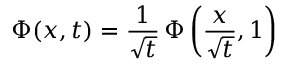<formula> <loc_0><loc_0><loc_500><loc_500>\Phi ( x , t ) = { \frac { 1 } { \sqrt { t } } } \, \Phi \left ( { \frac { x } { \sqrt { t } } } , 1 \right )</formula> 